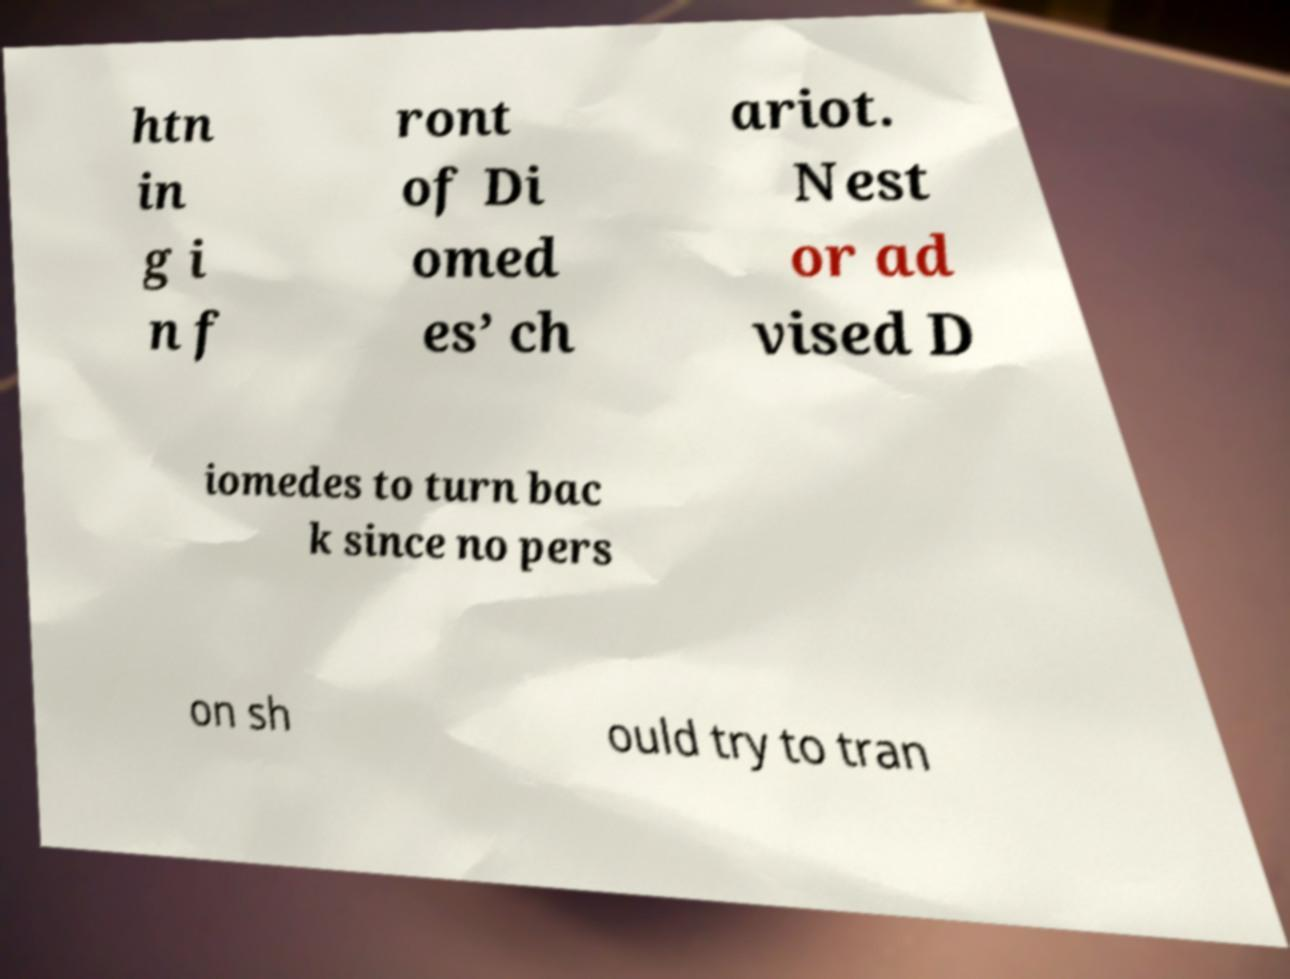Please read and relay the text visible in this image. What does it say? htn in g i n f ront of Di omed es’ ch ariot. Nest or ad vised D iomedes to turn bac k since no pers on sh ould try to tran 